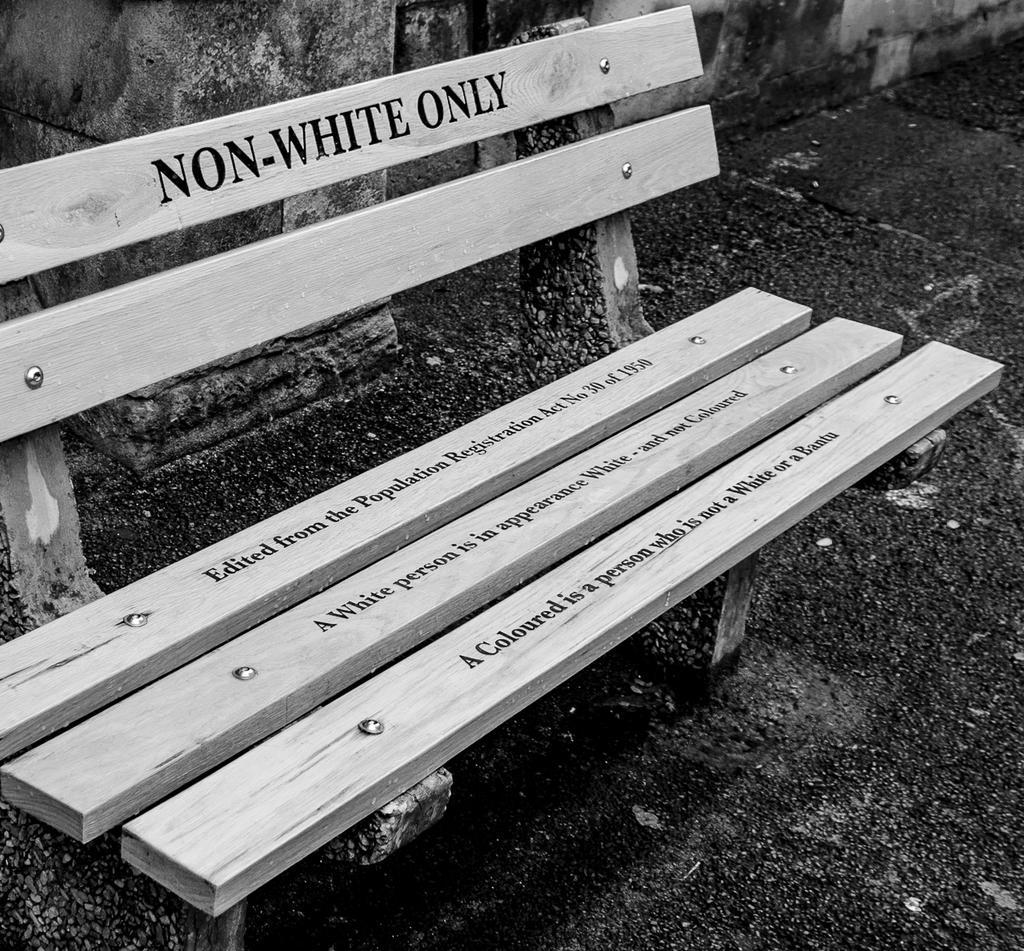Describe this image in one or two sentences. On the left side, there is a wooden bench, on which there are texts. In the background, there is a wall. 